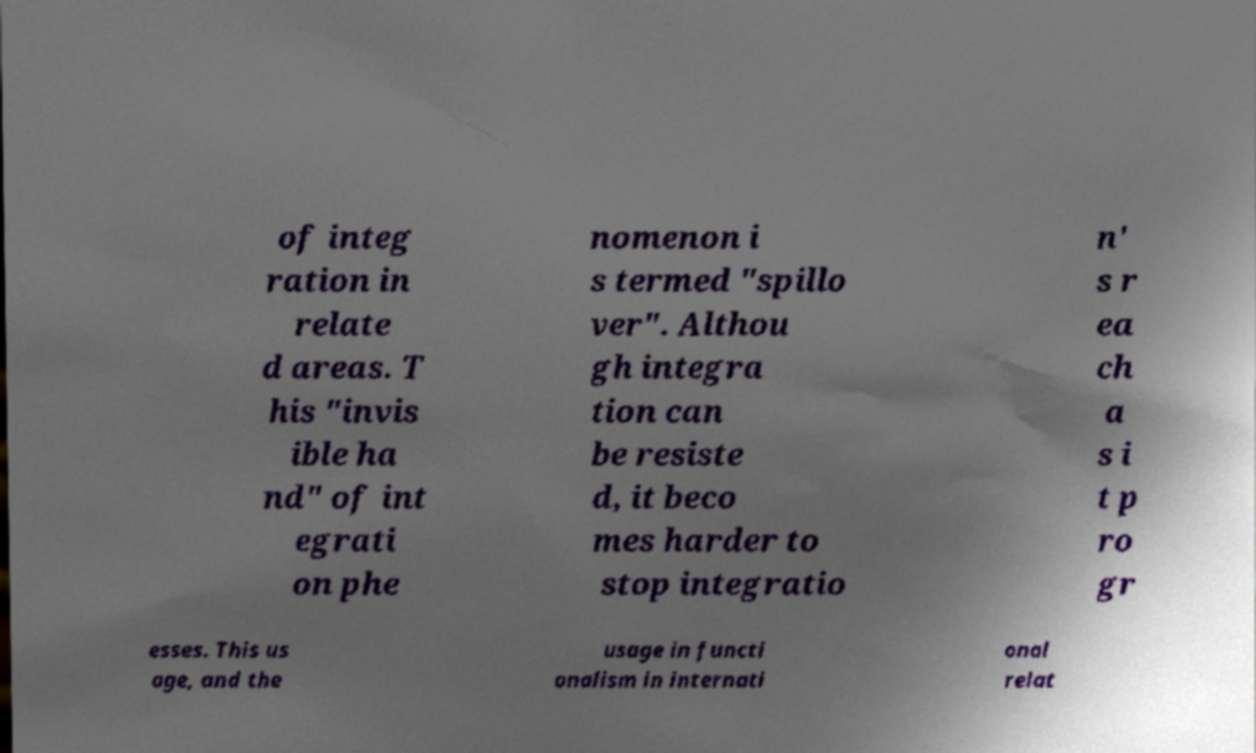Can you accurately transcribe the text from the provided image for me? of integ ration in relate d areas. T his "invis ible ha nd" of int egrati on phe nomenon i s termed "spillo ver". Althou gh integra tion can be resiste d, it beco mes harder to stop integratio n' s r ea ch a s i t p ro gr esses. This us age, and the usage in functi onalism in internati onal relat 